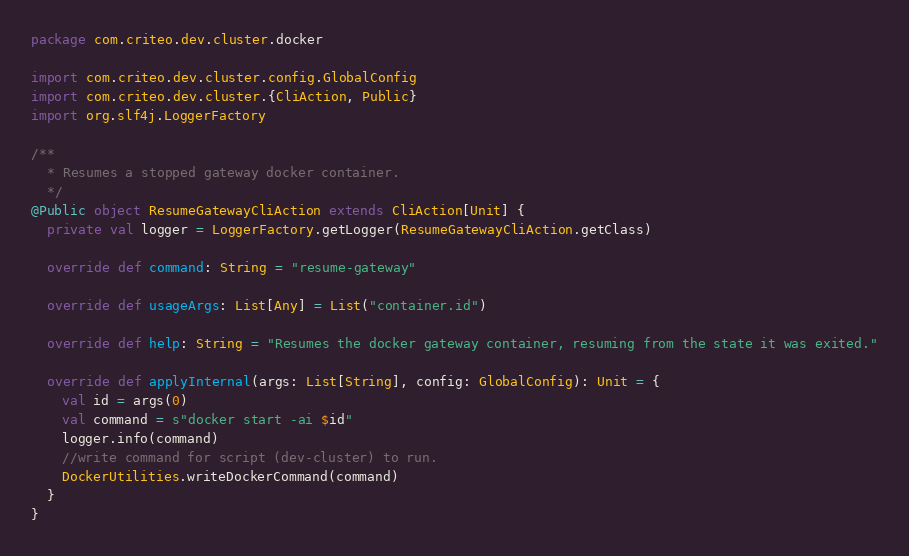<code> <loc_0><loc_0><loc_500><loc_500><_Scala_>package com.criteo.dev.cluster.docker

import com.criteo.dev.cluster.config.GlobalConfig
import com.criteo.dev.cluster.{CliAction, Public}
import org.slf4j.LoggerFactory

/**
  * Resumes a stopped gateway docker container.
  */
@Public object ResumeGatewayCliAction extends CliAction[Unit] {
  private val logger = LoggerFactory.getLogger(ResumeGatewayCliAction.getClass)

  override def command: String = "resume-gateway"

  override def usageArgs: List[Any] = List("container.id")

  override def help: String = "Resumes the docker gateway container, resuming from the state it was exited."

  override def applyInternal(args: List[String], config: GlobalConfig): Unit = {
    val id = args(0)
    val command = s"docker start -ai $id"
    logger.info(command)
    //write command for script (dev-cluster) to run.
    DockerUtilities.writeDockerCommand(command)
  }
}
</code> 